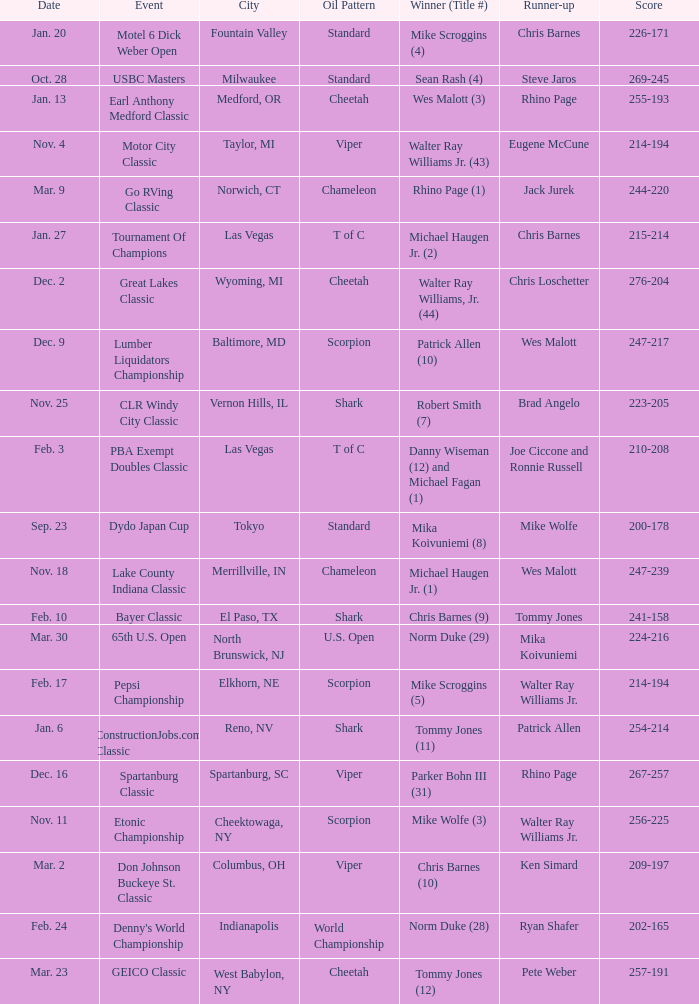Which Score has an Event of constructionjobs.com classic? 254-214. 